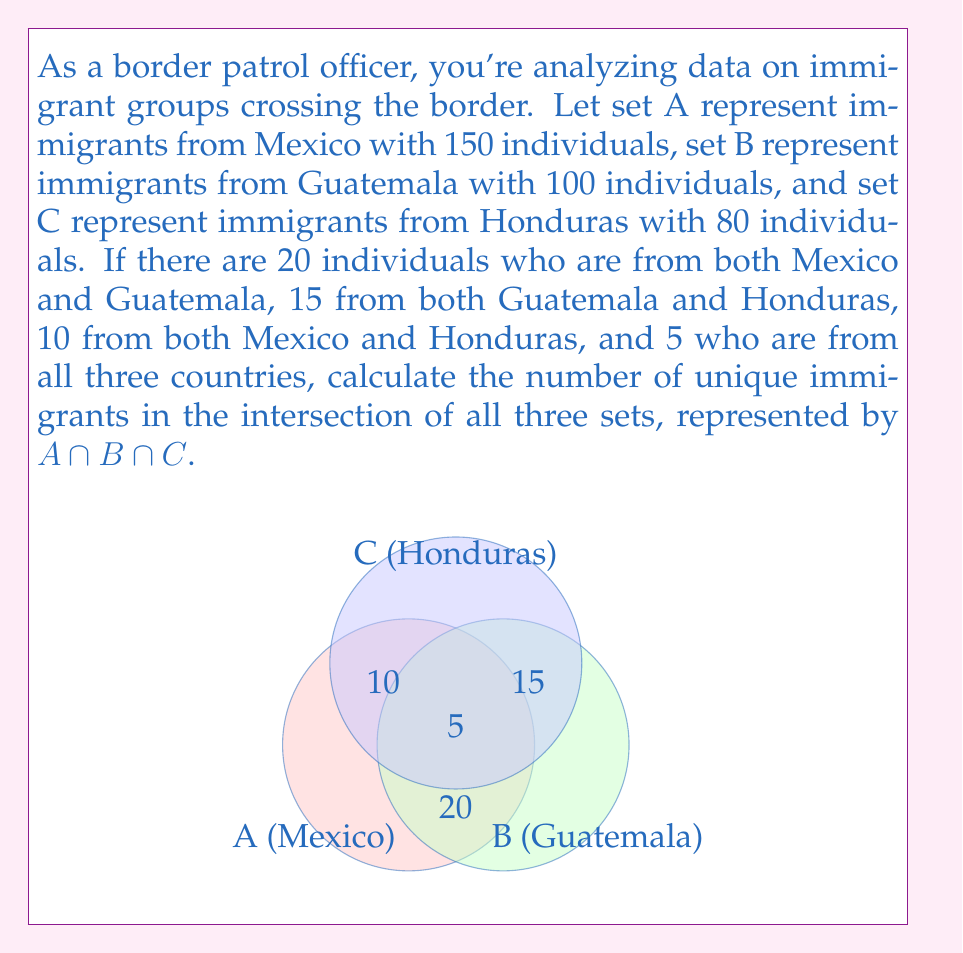Show me your answer to this math problem. Let's approach this step-by-step using set theory:

1) We're given that $|A \cap B \cap C| = 5$, which means 5 immigrants are from all three countries.

2) To find the unique immigrants in the intersection of all three sets, we need to use the principle of inclusion-exclusion:

   $|A \cup B \cup C| = |A| + |B| + |C| - |A \cap B| - |B \cap C| - |A \cap C| + |A \cap B \cap C|$

3) We're given:
   $|A| = 150$
   $|B| = 100$
   $|C| = 80$
   $|A \cap B| = 20$
   $|B \cap C| = 15$
   $|A \cap C| = 10$
   $|A \cap B \cap C| = 5$

4) Substituting these values:

   $|A \cup B \cup C| = 150 + 100 + 80 - 20 - 15 - 10 + 5 = 290$

5) Therefore, the number of unique immigrants from all three countries combined is 290.

6) The question asks specifically for $|A \cap B \cap C|$, which is given as 5.

Thus, the number of unique immigrants in the intersection of all three sets is 5.
Answer: 5 